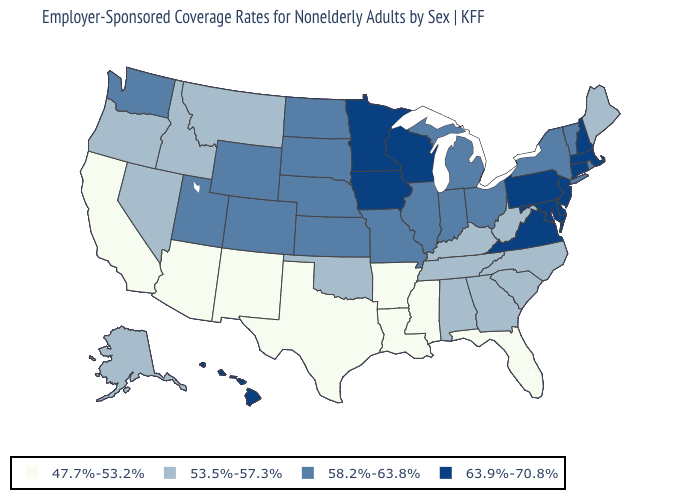Does Michigan have a higher value than Illinois?
Be succinct. No. Is the legend a continuous bar?
Answer briefly. No. Name the states that have a value in the range 58.2%-63.8%?
Answer briefly. Colorado, Illinois, Indiana, Kansas, Michigan, Missouri, Nebraska, New York, North Dakota, Ohio, Rhode Island, South Dakota, Utah, Vermont, Washington, Wyoming. Name the states that have a value in the range 63.9%-70.8%?
Concise answer only. Connecticut, Delaware, Hawaii, Iowa, Maryland, Massachusetts, Minnesota, New Hampshire, New Jersey, Pennsylvania, Virginia, Wisconsin. Does Maine have the lowest value in the Northeast?
Answer briefly. Yes. What is the value of Montana?
Give a very brief answer. 53.5%-57.3%. Which states have the highest value in the USA?
Answer briefly. Connecticut, Delaware, Hawaii, Iowa, Maryland, Massachusetts, Minnesota, New Hampshire, New Jersey, Pennsylvania, Virginia, Wisconsin. Does the first symbol in the legend represent the smallest category?
Give a very brief answer. Yes. Name the states that have a value in the range 53.5%-57.3%?
Answer briefly. Alabama, Alaska, Georgia, Idaho, Kentucky, Maine, Montana, Nevada, North Carolina, Oklahoma, Oregon, South Carolina, Tennessee, West Virginia. What is the value of Ohio?
Keep it brief. 58.2%-63.8%. Name the states that have a value in the range 47.7%-53.2%?
Give a very brief answer. Arizona, Arkansas, California, Florida, Louisiana, Mississippi, New Mexico, Texas. What is the highest value in the USA?
Keep it brief. 63.9%-70.8%. 